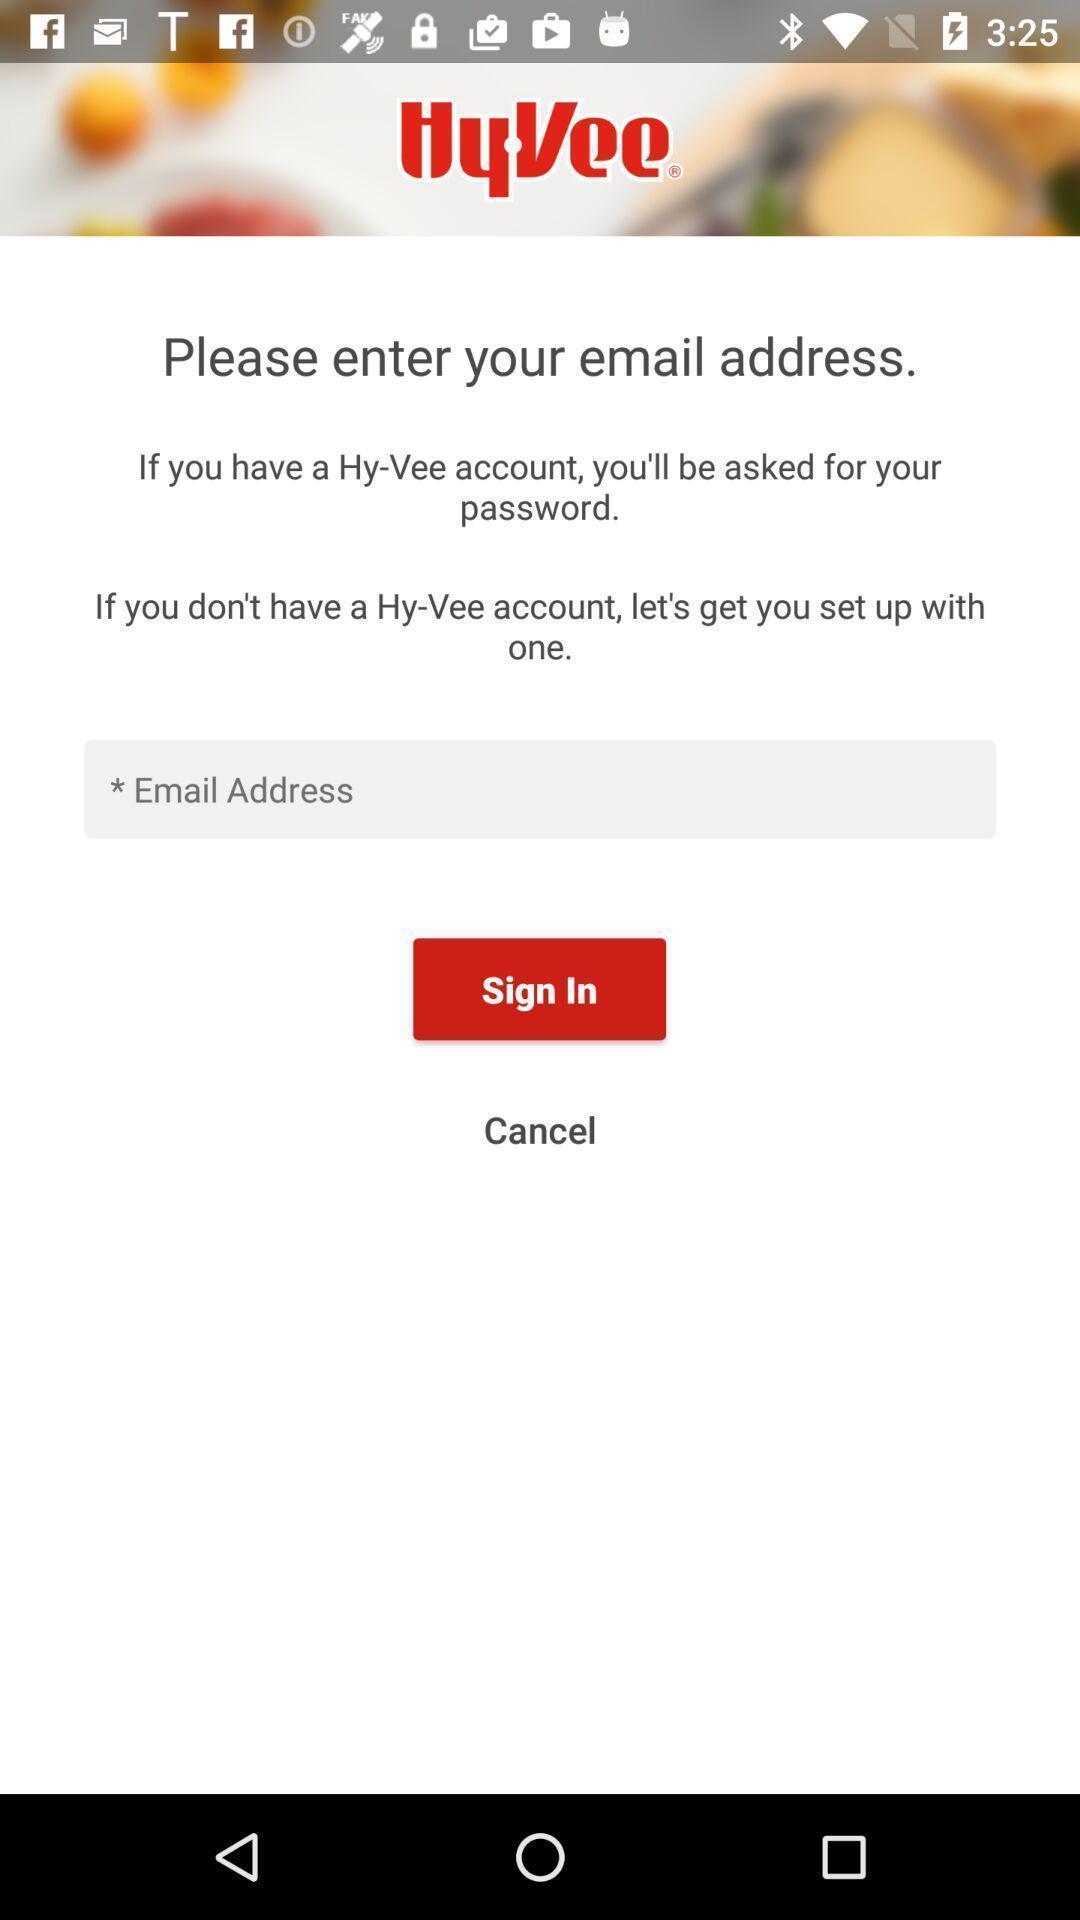Summarize the information in this screenshot. Sign in page. 